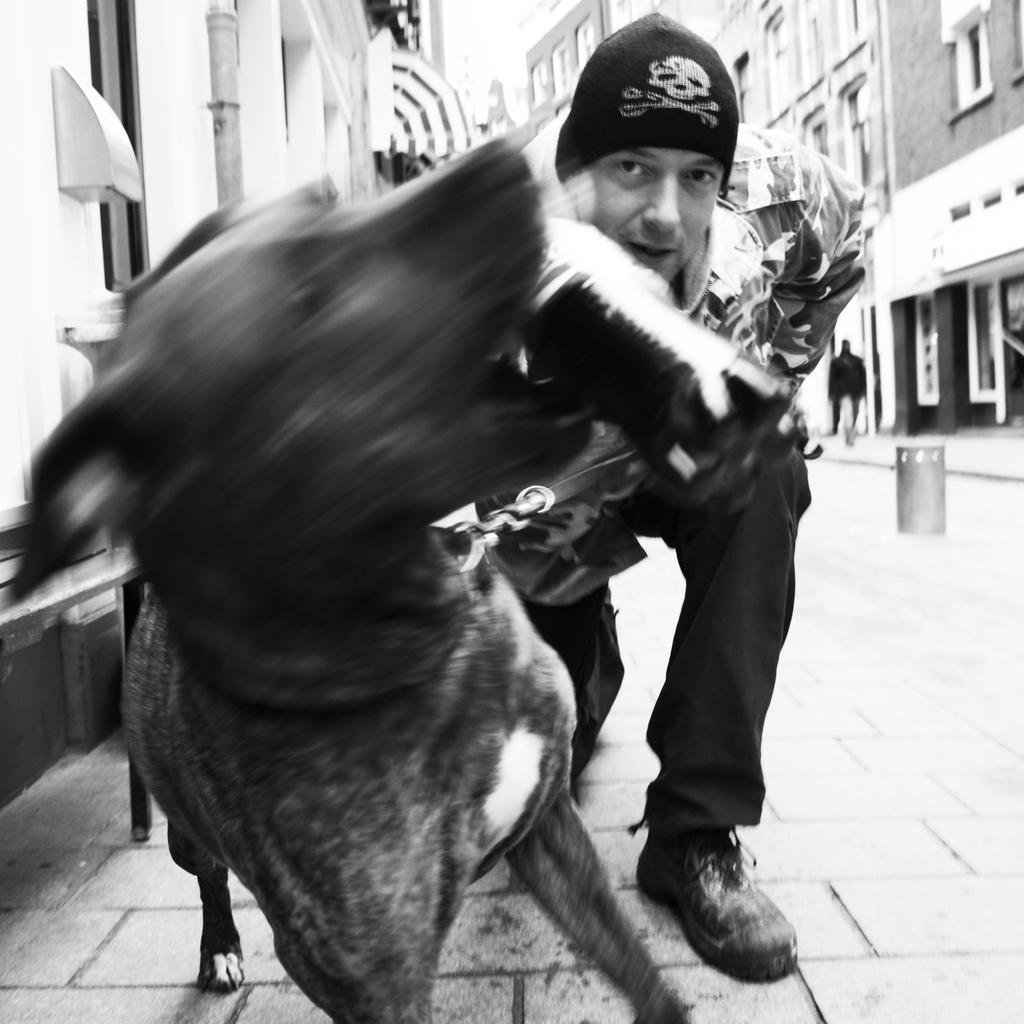Who is present in the image? There is a man and a dog in the image. What is the dog doing in the image? The dog is biting a bottle in the image. What can be seen in the background of the image? There is a building with windows in the background of the image. What type of market can be seen in the image? There is no market present in the image. Is the fireman in the image wearing his uniform? There is no fireman present in the image. 